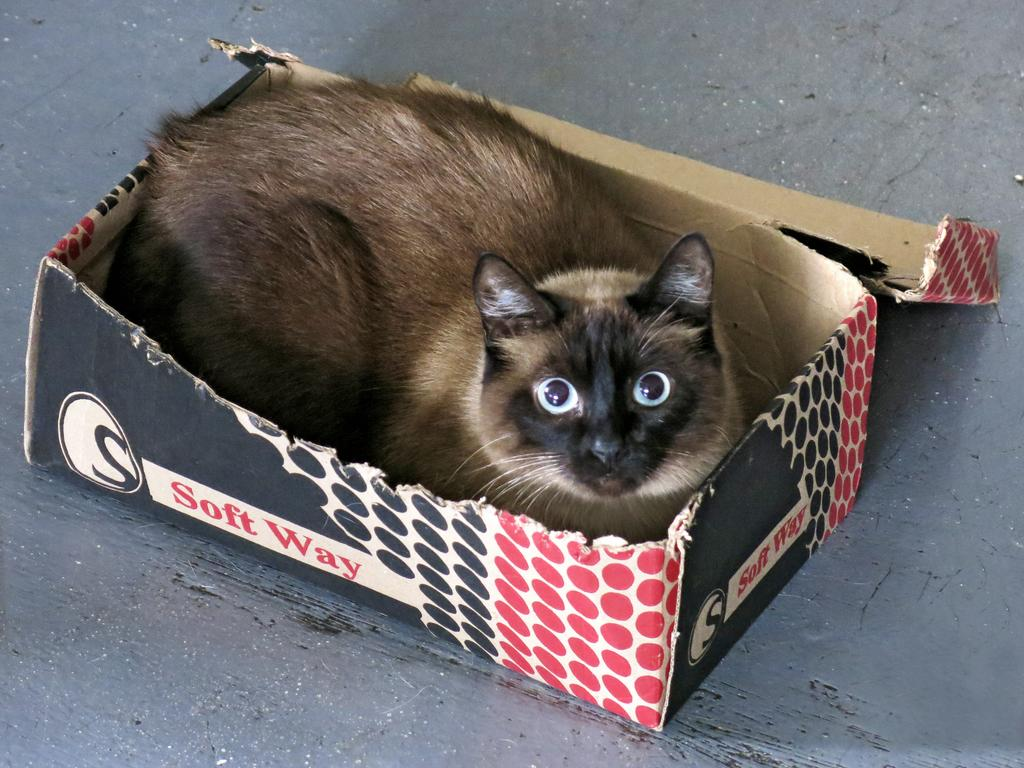What object is present in the image? There is a box in the image. What is inside the box? There is a cat in the box. What type of account is the cat using to access the internet in the image? There is no indication in the image that the cat is accessing the internet or using any type of account. 